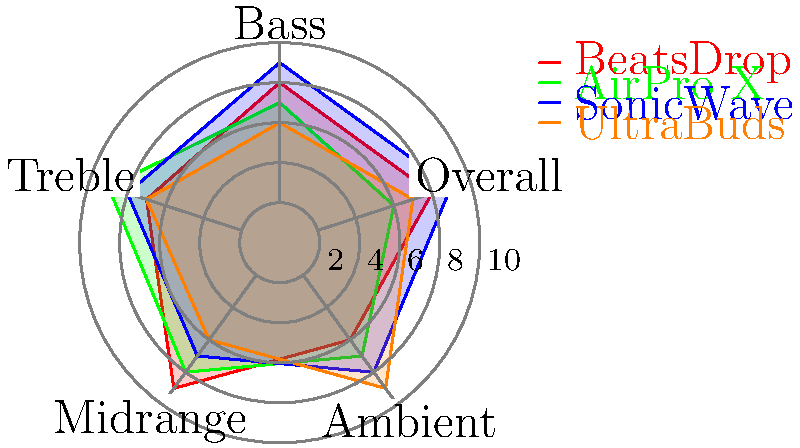You're shopping for new wireless earbuds and want to impress your friends with the best noise-cancellation. Based on the radar chart showing noise-cancellation levels for different wireless earbuds, which brand offers the highest overall noise-cancellation performance? To determine which brand offers the highest overall noise-cancellation performance, we need to compare the "Overall" scores for each brand on the radar chart. Let's examine the data step-by-step:

1. Identify the "Overall" axis on the radar chart (bottom-right spoke).
2. Compare the values for each brand on this axis:

   - BeatsDrop (red): 8
   - AirPro X (green): 6
   - SonicWave (blue): 9
   - UltraBuds (orange): 7

3. Find the highest value among these overall scores.

The highest overall score is 9, which corresponds to the SonicWave brand (blue line).

While other brands may excel in specific areas (e.g., AirPro X has better treble performance), SonicWave has the best overall noise-cancellation performance, which is what the question asks for.
Answer: SonicWave 